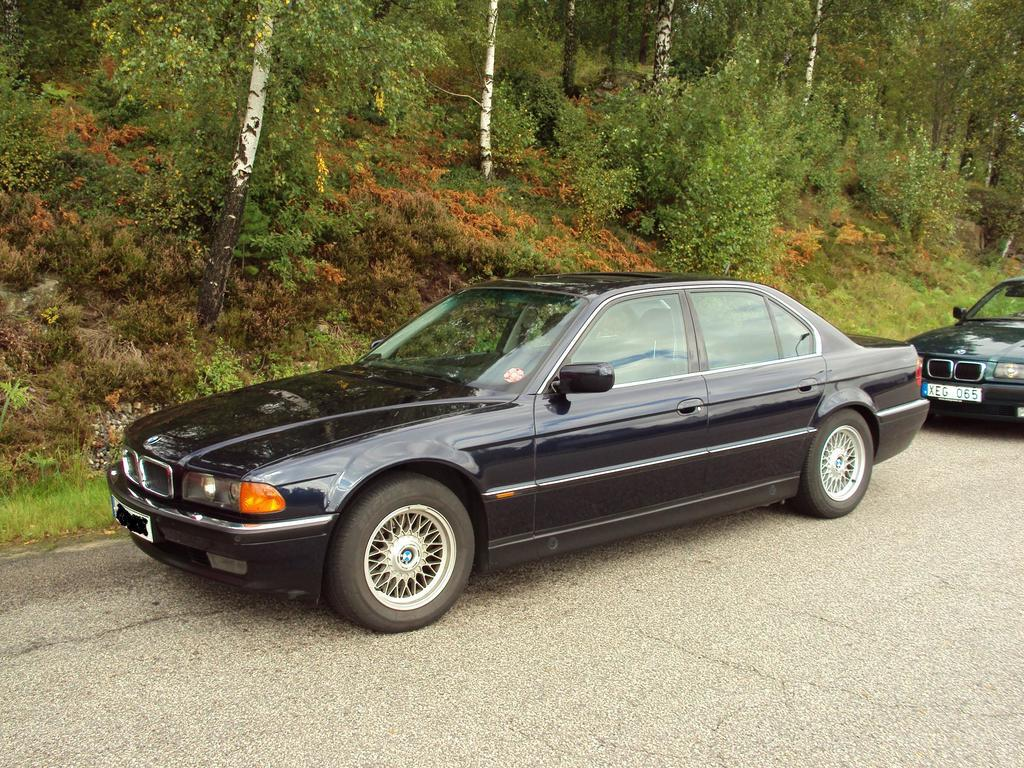What can be seen on the road in the image? There are cars on the road in the image. What is located on the hill beside the road? There are trees and plants on the hill beside the road. What type of industry can be seen in the image? There is no industry present in the image; it features cars on a road and trees and plants on a hill. Can you tell me how many church bells are ringing in the image? There are no church bells or a church present in the image. 